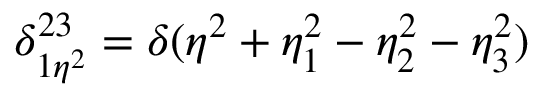<formula> <loc_0><loc_0><loc_500><loc_500>\delta _ { 1 \eta ^ { 2 } } ^ { 2 3 } = \delta ( \eta ^ { 2 } + \eta _ { 1 } ^ { 2 } - \eta _ { 2 } ^ { 2 } - \eta _ { 3 } ^ { 2 } )</formula> 